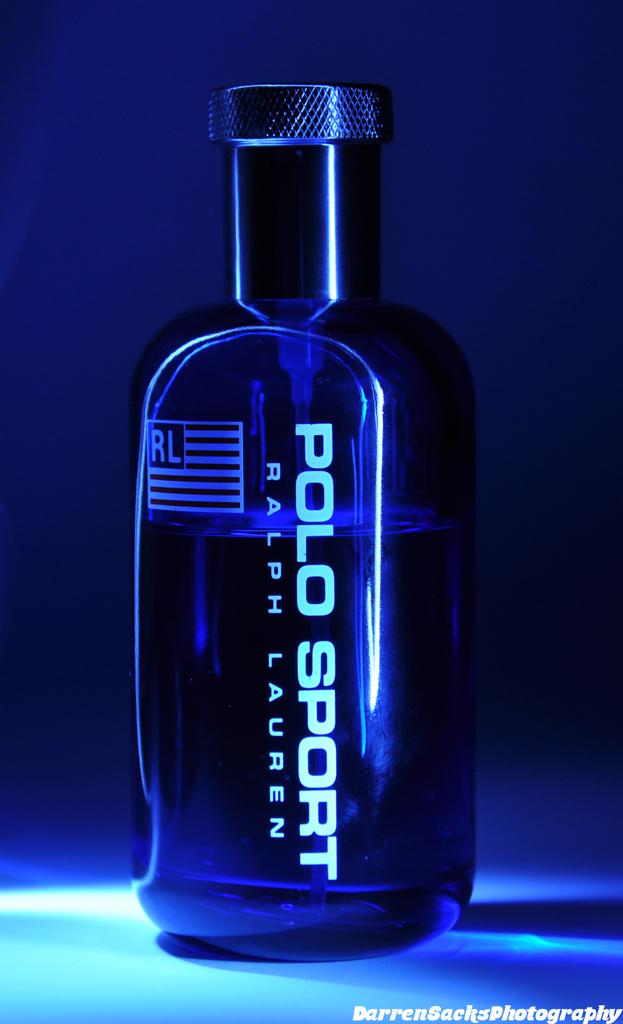What common designer brand is pictured here?
Provide a short and direct response. Ralph lauren. Who owns this photo?
Keep it short and to the point. Darren sacks photography. 